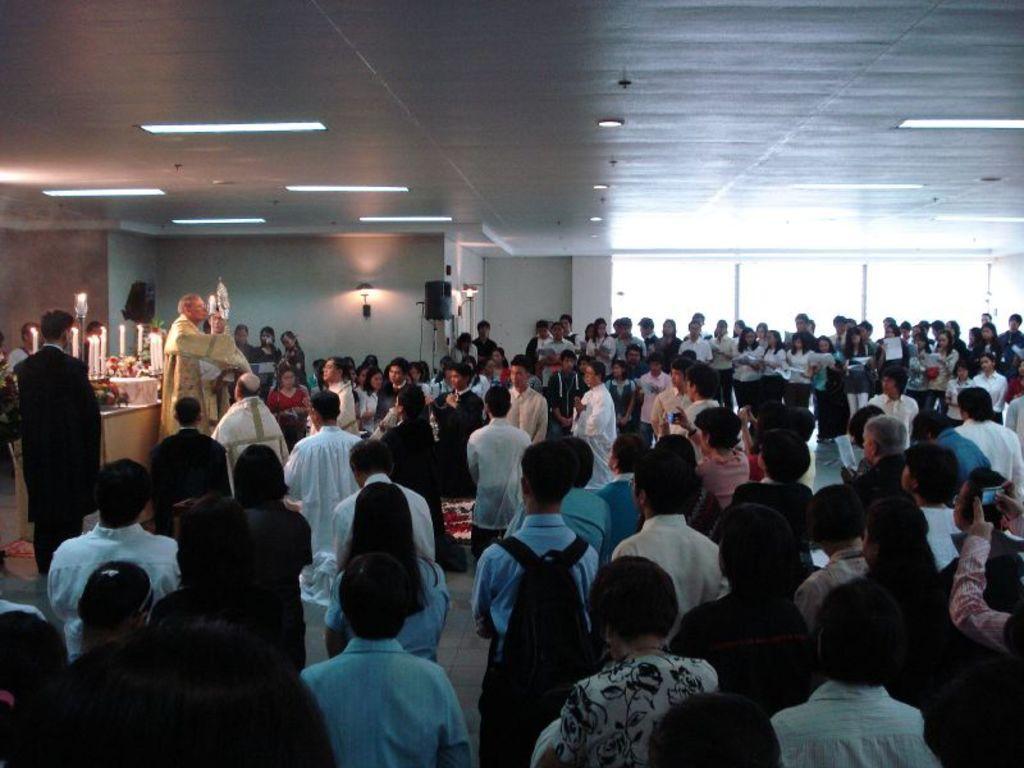Please provide a concise description of this image. In this image we can see persons standing on the floor. On the left side of the image we can see persons, tables and candles. In the background we can see windows and wall. 